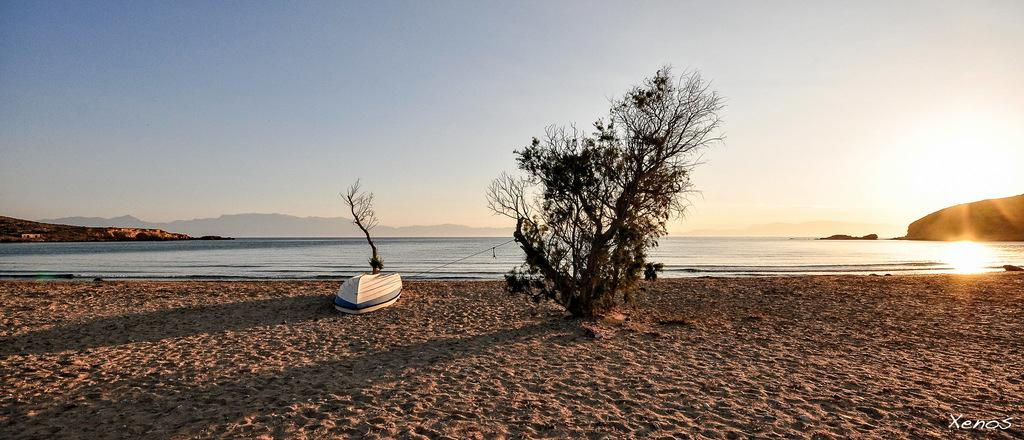What is the main subject of the image? There is a boat in the image. What can be seen on the ground in the image? There are trees visible on the ground in the image. What is visible in the background of the image? Mountains, water, and the sky are visible in the background of the image. What type of reward is being given to the ship in the image? There is no ship present in the image, and therefore no reward can be given. How does the lift function in the image? There is no lift present in the image, so its function cannot be described. 